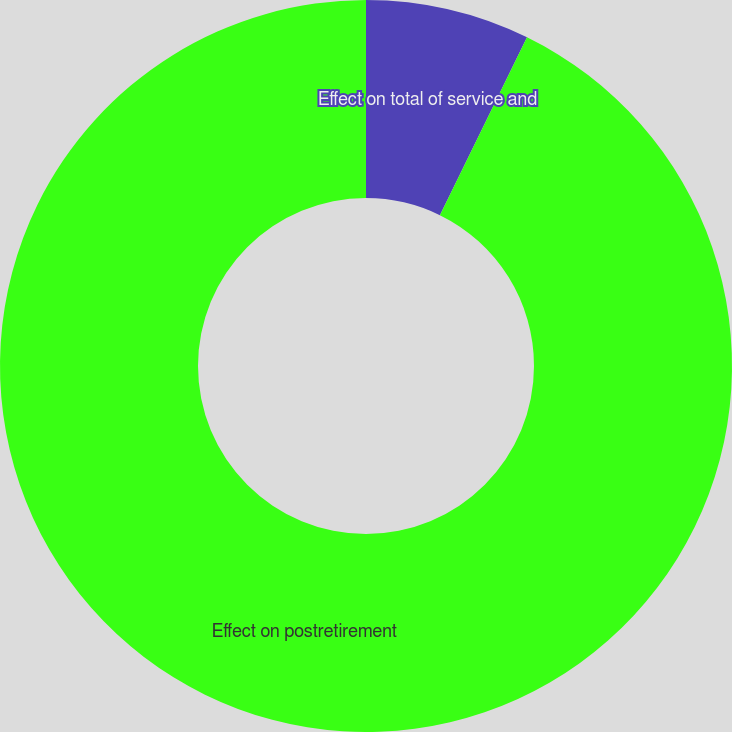Convert chart. <chart><loc_0><loc_0><loc_500><loc_500><pie_chart><fcel>Effect on total of service and<fcel>Effect on postretirement<nl><fcel>7.25%<fcel>92.75%<nl></chart> 